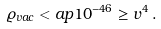<formula> <loc_0><loc_0><loc_500><loc_500>\varrho _ { v a c } < a p 1 0 ^ { - 4 6 } \geq v ^ { 4 } \, .</formula> 